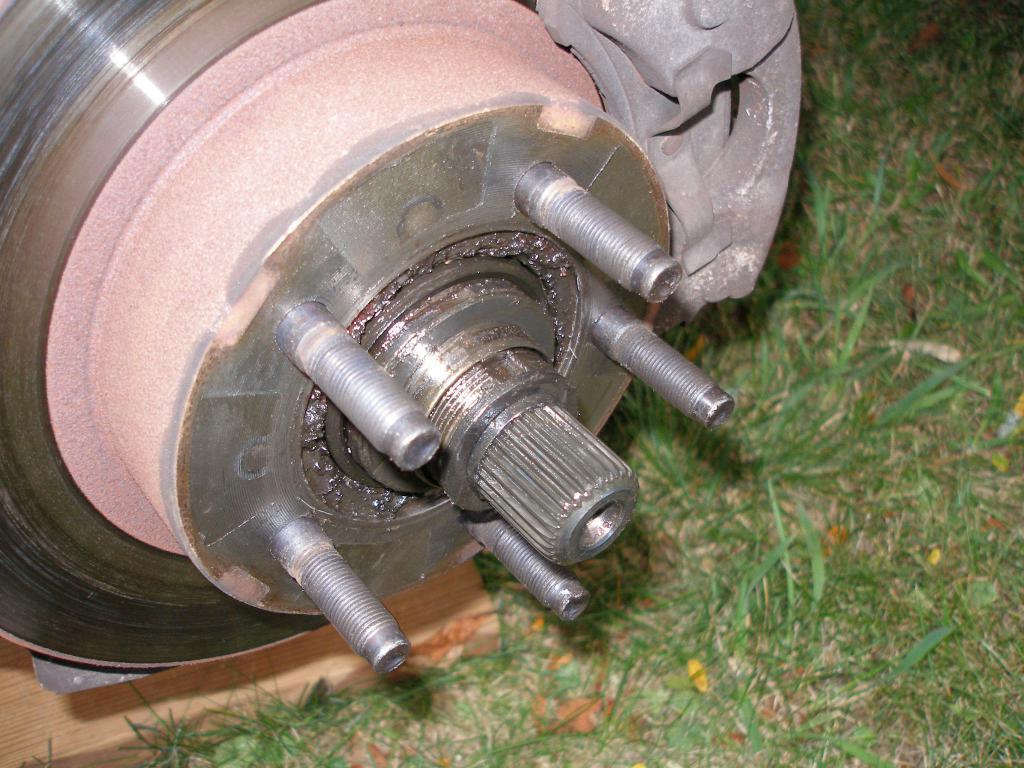Can you describe this image briefly? In the picture we can see a wheel axle of a car with break plates and bolts to it and under it we can see a wooden plank on the grass surface. 